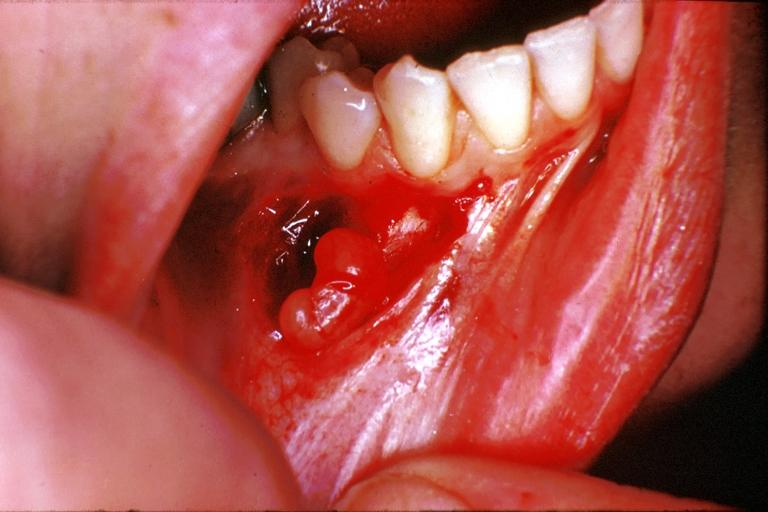does foot show traumatic neuroma?
Answer the question using a single word or phrase. No 